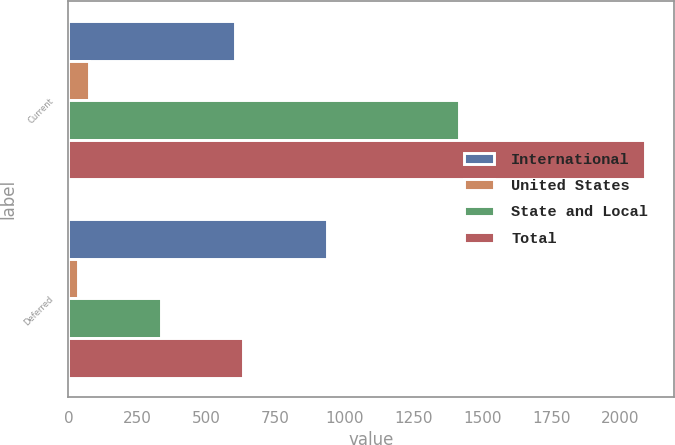Convert chart to OTSL. <chart><loc_0><loc_0><loc_500><loc_500><stacked_bar_chart><ecel><fcel>Current<fcel>Deferred<nl><fcel>International<fcel>602<fcel>936<nl><fcel>United States<fcel>74<fcel>33<nl><fcel>State and Local<fcel>1415<fcel>337<nl><fcel>Total<fcel>2091<fcel>632<nl></chart> 